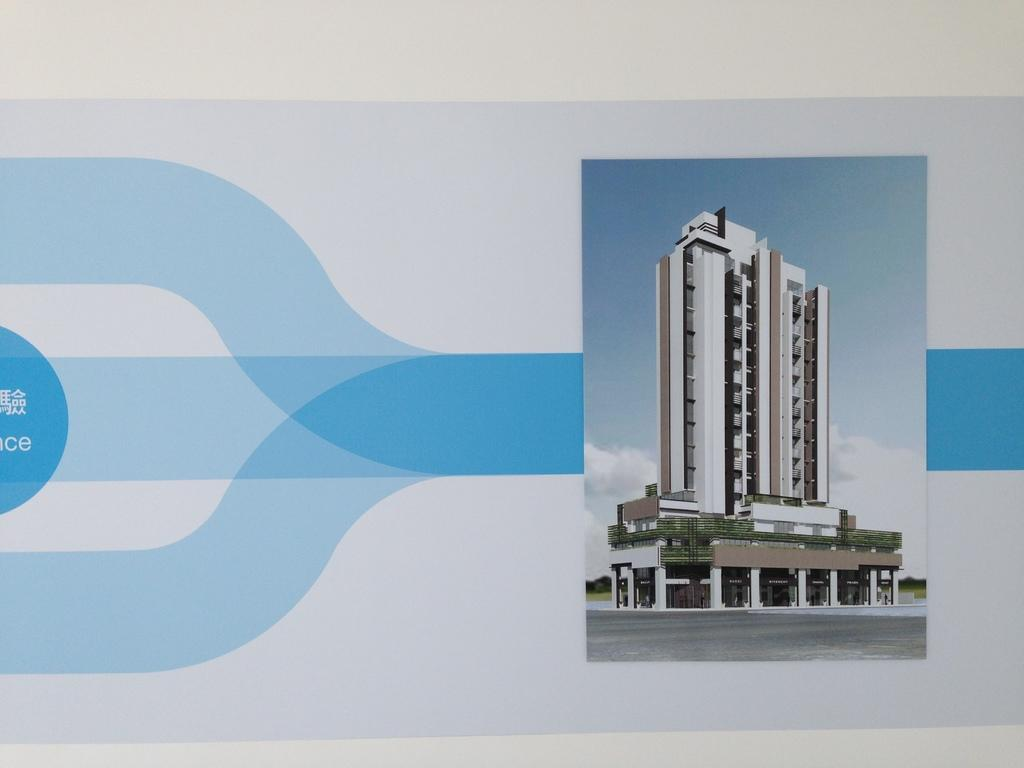What type of image is being described? The image appears to be a banner. What is shown on the banner? There is a building depicted on the banner. What can be seen in the background of the banner? The sky is visible behind the building on the banner. How many brothers are present in the image? There is no mention of any brothers in the image, as it only features a building and the sky. 